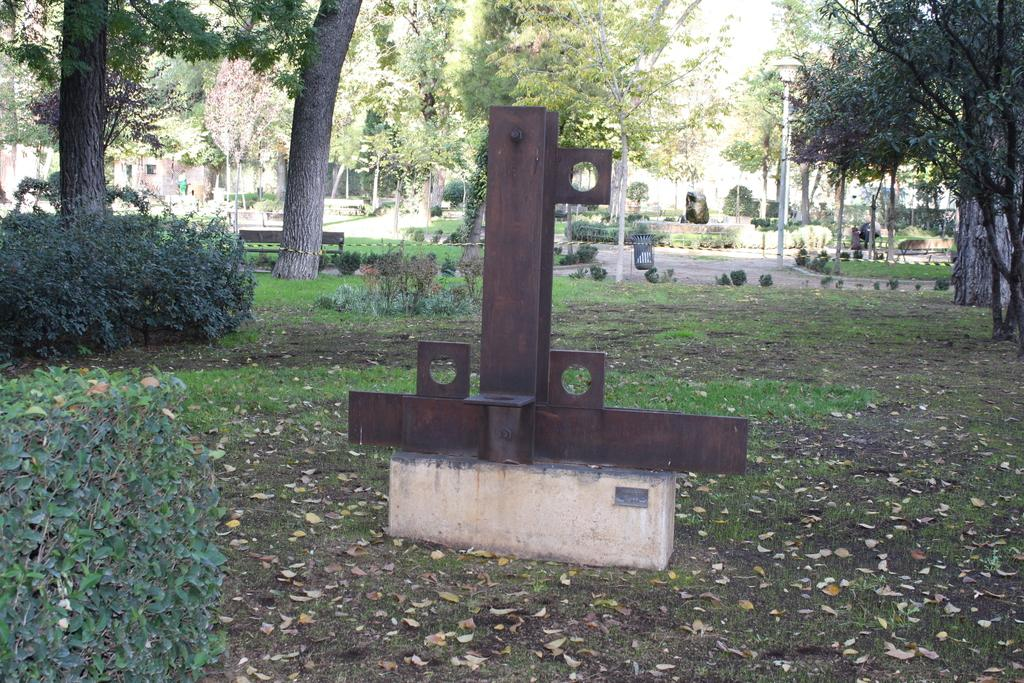What type of object is made of metal in the image? There is a metal object in the image, but it is not specified what kind of object it is. What type of vegetation is present in the image? There are plants and trees in the image. What is the pole in the image supporting? The pole in the image is supporting a light. What type of event is happening in the image involving the plants? There is no event involving the plants in the image; they are simply present in the scene. How do the plants fall from the pole in the image? The plants do not fall from the pole in the image; there is no pole with plants in the image. 